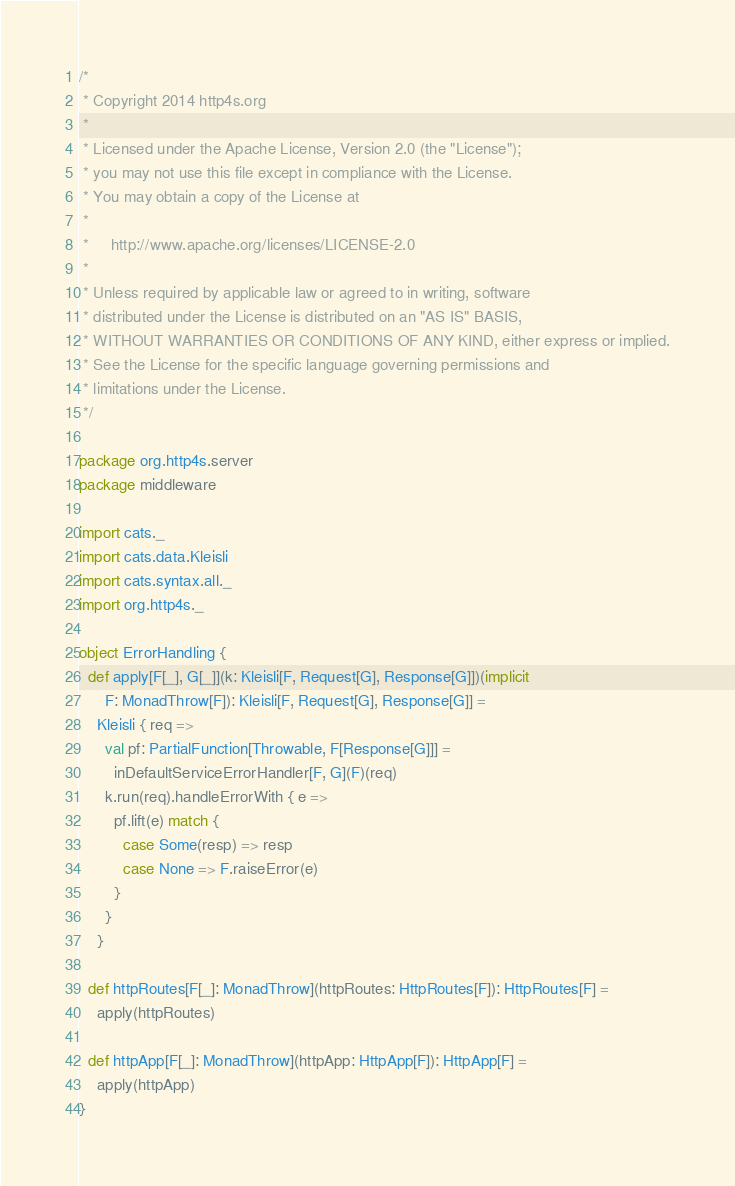<code> <loc_0><loc_0><loc_500><loc_500><_Scala_>/*
 * Copyright 2014 http4s.org
 *
 * Licensed under the Apache License, Version 2.0 (the "License");
 * you may not use this file except in compliance with the License.
 * You may obtain a copy of the License at
 *
 *     http://www.apache.org/licenses/LICENSE-2.0
 *
 * Unless required by applicable law or agreed to in writing, software
 * distributed under the License is distributed on an "AS IS" BASIS,
 * WITHOUT WARRANTIES OR CONDITIONS OF ANY KIND, either express or implied.
 * See the License for the specific language governing permissions and
 * limitations under the License.
 */

package org.http4s.server
package middleware

import cats._
import cats.data.Kleisli
import cats.syntax.all._
import org.http4s._

object ErrorHandling {
  def apply[F[_], G[_]](k: Kleisli[F, Request[G], Response[G]])(implicit
      F: MonadThrow[F]): Kleisli[F, Request[G], Response[G]] =
    Kleisli { req =>
      val pf: PartialFunction[Throwable, F[Response[G]]] =
        inDefaultServiceErrorHandler[F, G](F)(req)
      k.run(req).handleErrorWith { e =>
        pf.lift(e) match {
          case Some(resp) => resp
          case None => F.raiseError(e)
        }
      }
    }

  def httpRoutes[F[_]: MonadThrow](httpRoutes: HttpRoutes[F]): HttpRoutes[F] =
    apply(httpRoutes)

  def httpApp[F[_]: MonadThrow](httpApp: HttpApp[F]): HttpApp[F] =
    apply(httpApp)
}
</code> 